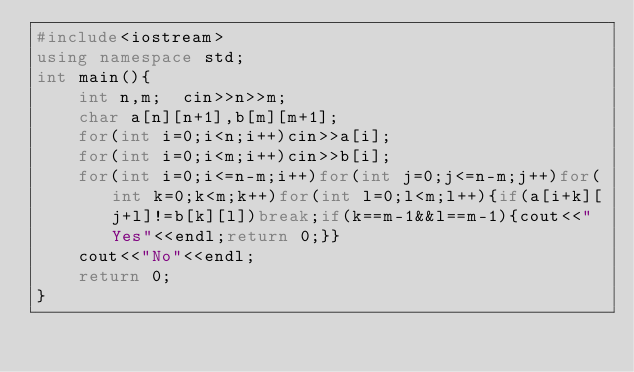Convert code to text. <code><loc_0><loc_0><loc_500><loc_500><_C++_>#include<iostream>
using namespace std;
int main(){
    int n,m;  cin>>n>>m;
    char a[n][n+1],b[m][m+1];
    for(int i=0;i<n;i++)cin>>a[i];
    for(int i=0;i<m;i++)cin>>b[i];
    for(int i=0;i<=n-m;i++)for(int j=0;j<=n-m;j++)for(int k=0;k<m;k++)for(int l=0;l<m;l++){if(a[i+k][j+l]!=b[k][l])break;if(k==m-1&&l==m-1){cout<<"Yes"<<endl;return 0;}}
    cout<<"No"<<endl;
    return 0;
}</code> 